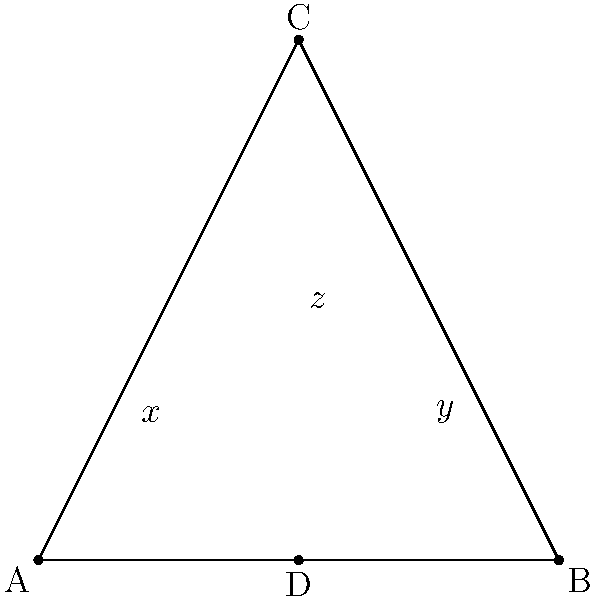In the triangle ABC, a line is drawn from vertex C to the midpoint D of side AB, representing the balance between independence (sides AC and BC) and social connections (base AB). If angle CAD is $x$, angle CBD is $y$, and angle ACD is $z$, what is the relationship between $x$, $y$, and $z$? To solve this problem, let's follow these steps:

1) First, recall that the sum of angles in a triangle is always 180°.

2) In triangle ACD:
   $x + z + \angle ADC = 180°$ ... (Equation 1)

3) In triangle BCD:
   $y + z + \angle BDC = 180°$ ... (Equation 2)

4) Since CD is drawn to the midpoint of AB, triangles ACD and BCD are congruent. This means that $\angle ADC = \angle BDC$.

5) Let's call this angle $w$. So, $\angle ADC = \angle BDC = w$.

6) Substituting in Equations 1 and 2:
   $x + z + w = 180°$ ... (Equation 3)
   $y + z + w = 180°$ ... (Equation 4)

7) Since the right sides of Equations 3 and 4 are equal, we can set the left sides equal:
   $x + z + w = y + z + w$

8) The $z$ and $w$ cancel out on both sides, leaving us with:
   $x = y$

Therefore, the relationship between $x$, $y$, and $z$ is that $x = y$.
Answer: $x = y$ 